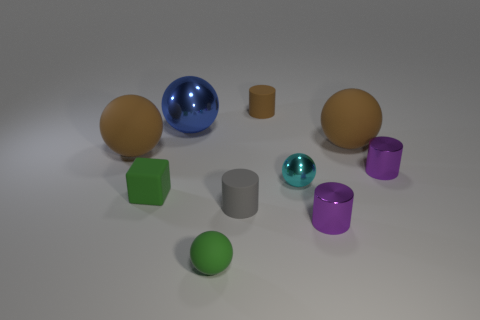Subtract all green cylinders. How many brown balls are left? 2 Subtract all small cyan metallic balls. How many balls are left? 4 Subtract 1 balls. How many balls are left? 4 Subtract all cyan spheres. How many spheres are left? 4 Subtract all cyan cylinders. Subtract all cyan spheres. How many cylinders are left? 4 Subtract all cylinders. How many objects are left? 6 Add 7 cyan shiny balls. How many cyan shiny balls exist? 8 Subtract 1 green blocks. How many objects are left? 9 Subtract all large brown rubber objects. Subtract all blue balls. How many objects are left? 7 Add 5 large rubber objects. How many large rubber objects are left? 7 